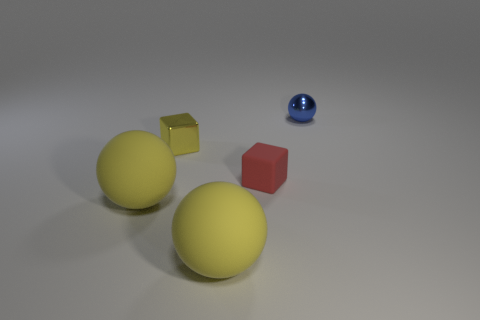Add 1 blue shiny things. How many objects exist? 6 Subtract all cubes. How many objects are left? 3 Subtract 0 cyan balls. How many objects are left? 5 Subtract all large red cylinders. Subtract all tiny balls. How many objects are left? 4 Add 1 tiny spheres. How many tiny spheres are left? 2 Add 3 tiny purple cubes. How many tiny purple cubes exist? 3 